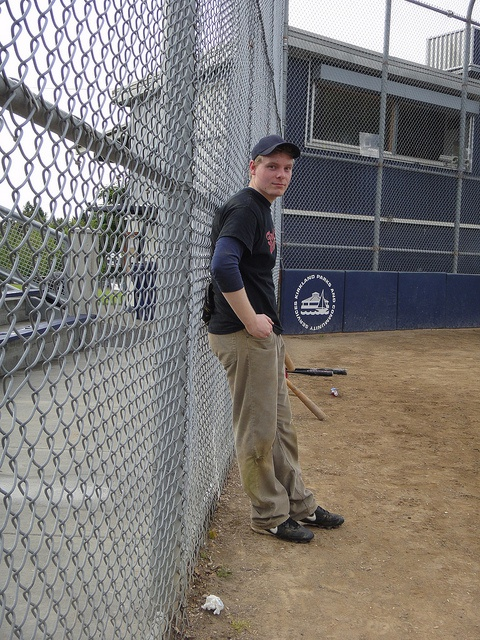Describe the objects in this image and their specific colors. I can see people in darkgray, gray, and black tones, baseball bat in darkgray, gray, tan, and maroon tones, and baseball bat in darkgray, black, and gray tones in this image. 